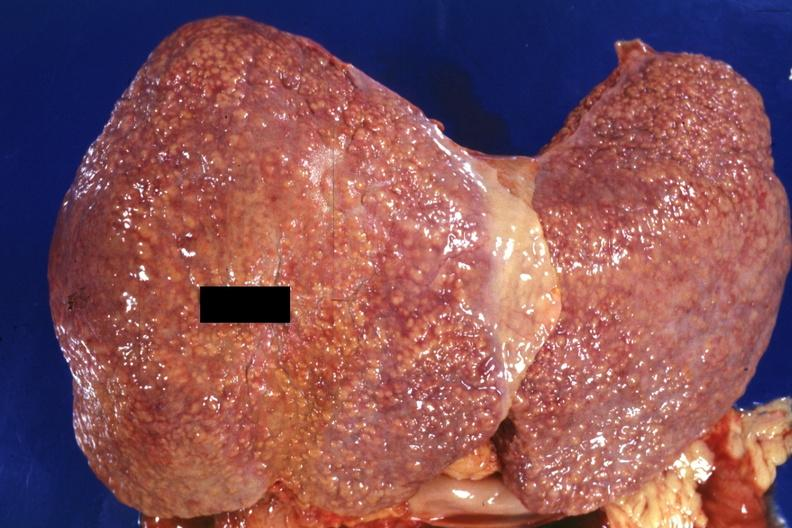how does this image show external view of large liver?
Answer the question using a single word or phrase. With obvious cirrhosis excellent example 